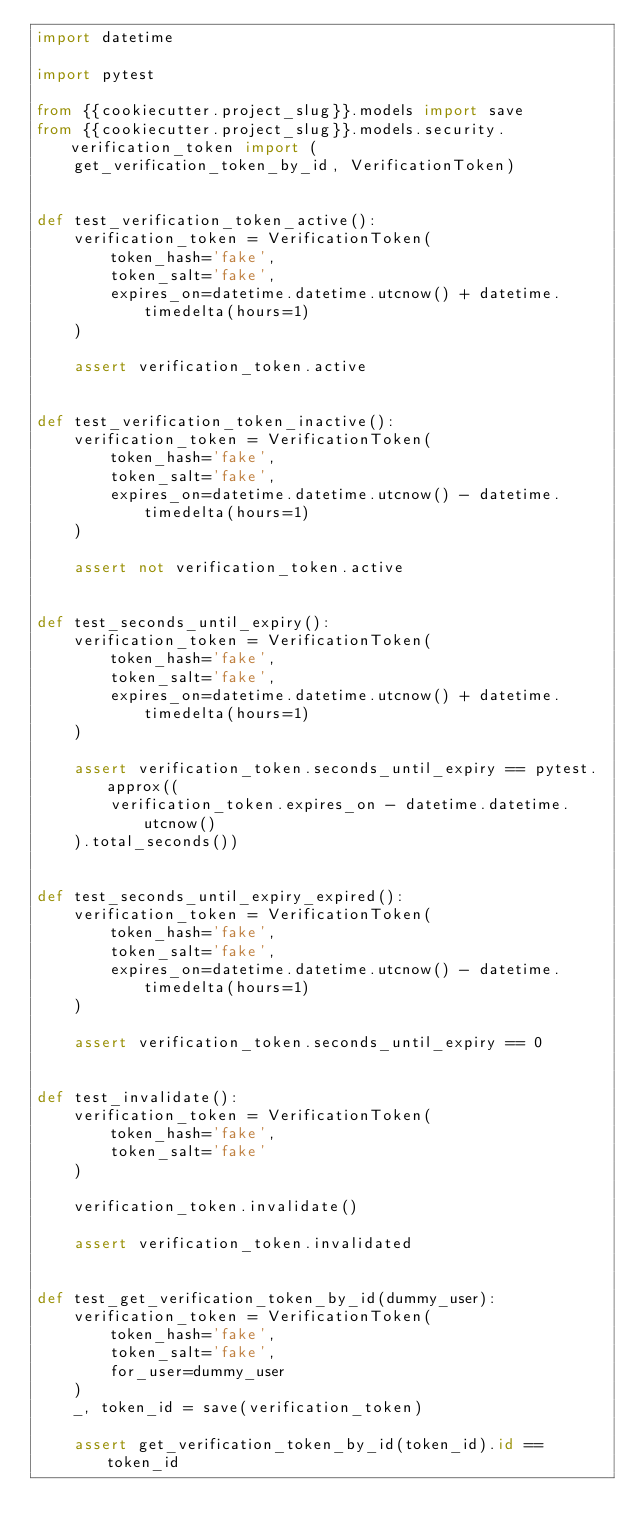Convert code to text. <code><loc_0><loc_0><loc_500><loc_500><_Python_>import datetime

import pytest

from {{cookiecutter.project_slug}}.models import save
from {{cookiecutter.project_slug}}.models.security.verification_token import (
    get_verification_token_by_id, VerificationToken)


def test_verification_token_active():
    verification_token = VerificationToken(
        token_hash='fake',
        token_salt='fake',
        expires_on=datetime.datetime.utcnow() + datetime.timedelta(hours=1)
    )

    assert verification_token.active


def test_verification_token_inactive():
    verification_token = VerificationToken(
        token_hash='fake',
        token_salt='fake',
        expires_on=datetime.datetime.utcnow() - datetime.timedelta(hours=1)
    )

    assert not verification_token.active


def test_seconds_until_expiry():
    verification_token = VerificationToken(
        token_hash='fake',
        token_salt='fake',
        expires_on=datetime.datetime.utcnow() + datetime.timedelta(hours=1)
    )

    assert verification_token.seconds_until_expiry == pytest.approx((
        verification_token.expires_on - datetime.datetime.utcnow()
    ).total_seconds())


def test_seconds_until_expiry_expired():
    verification_token = VerificationToken(
        token_hash='fake',
        token_salt='fake',
        expires_on=datetime.datetime.utcnow() - datetime.timedelta(hours=1)
    )

    assert verification_token.seconds_until_expiry == 0


def test_invalidate():
    verification_token = VerificationToken(
        token_hash='fake',
        token_salt='fake'
    )

    verification_token.invalidate()

    assert verification_token.invalidated


def test_get_verification_token_by_id(dummy_user):
    verification_token = VerificationToken(
        token_hash='fake',
        token_salt='fake',
        for_user=dummy_user
    )
    _, token_id = save(verification_token)

    assert get_verification_token_by_id(token_id).id == token_id
</code> 